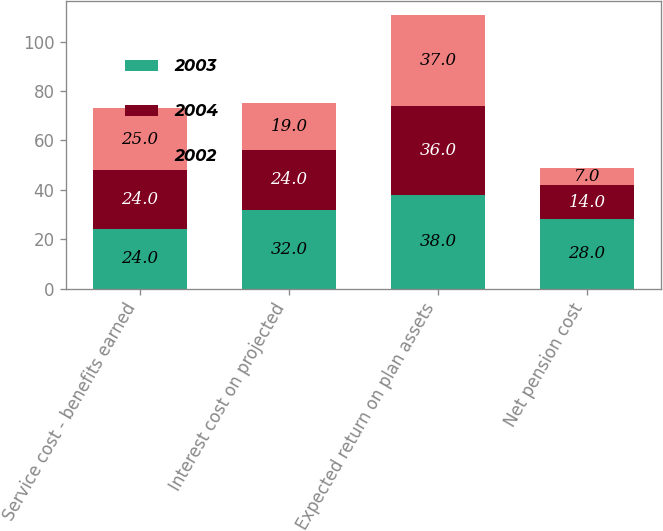Convert chart. <chart><loc_0><loc_0><loc_500><loc_500><stacked_bar_chart><ecel><fcel>Service cost - benefits earned<fcel>Interest cost on projected<fcel>Expected return on plan assets<fcel>Net pension cost<nl><fcel>2003<fcel>24<fcel>32<fcel>38<fcel>28<nl><fcel>2004<fcel>24<fcel>24<fcel>36<fcel>14<nl><fcel>2002<fcel>25<fcel>19<fcel>37<fcel>7<nl></chart> 